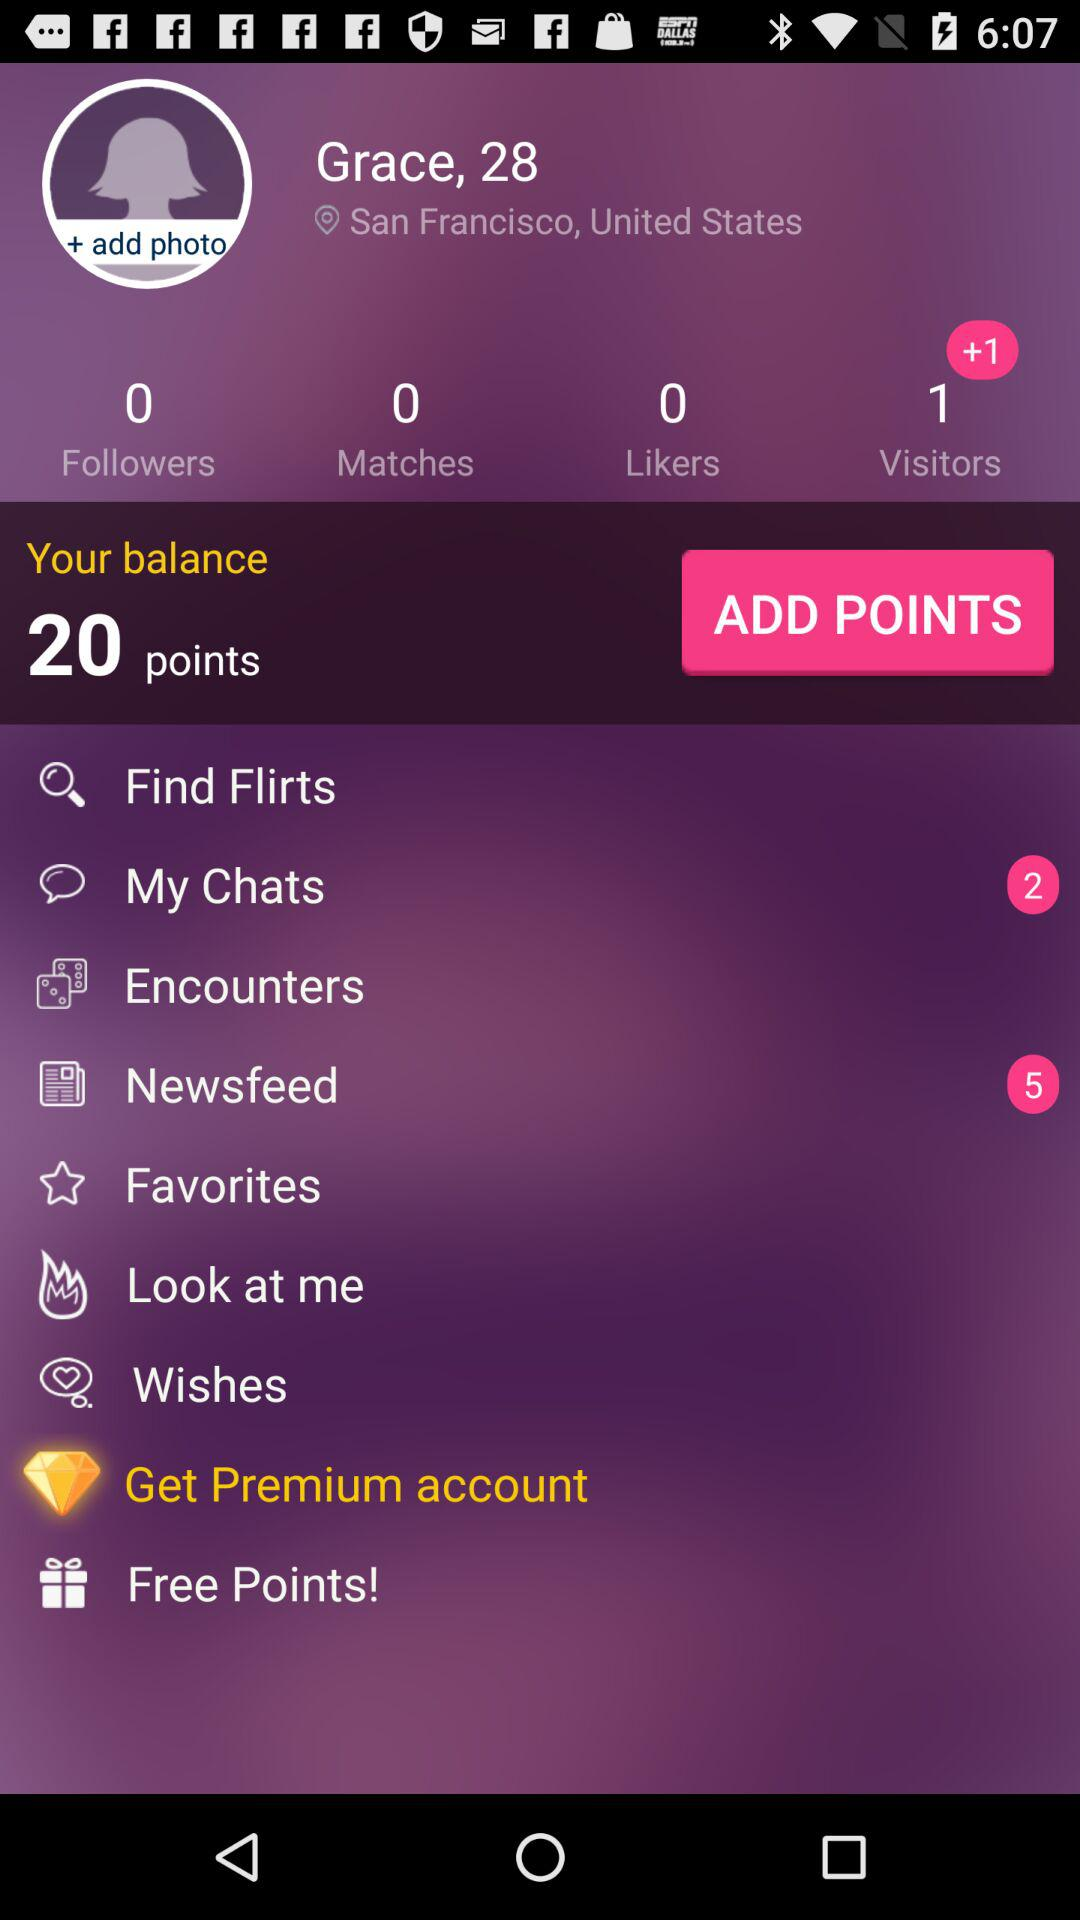Is there any unread chat? There are 2 unread chats. 